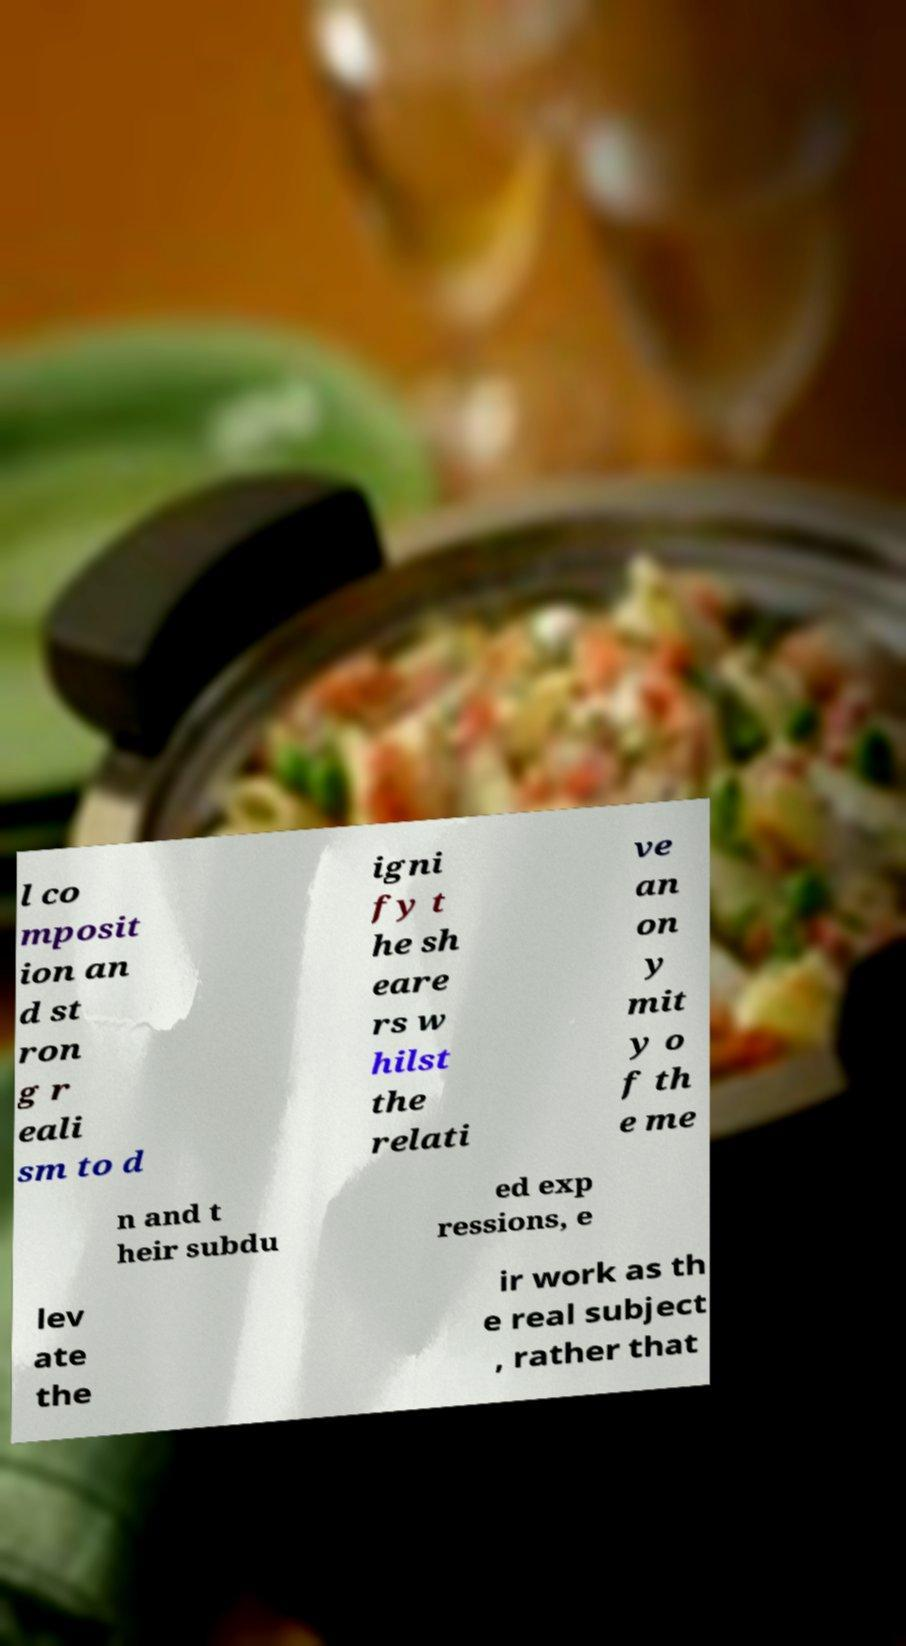Could you assist in decoding the text presented in this image and type it out clearly? l co mposit ion an d st ron g r eali sm to d igni fy t he sh eare rs w hilst the relati ve an on y mit y o f th e me n and t heir subdu ed exp ressions, e lev ate the ir work as th e real subject , rather that 